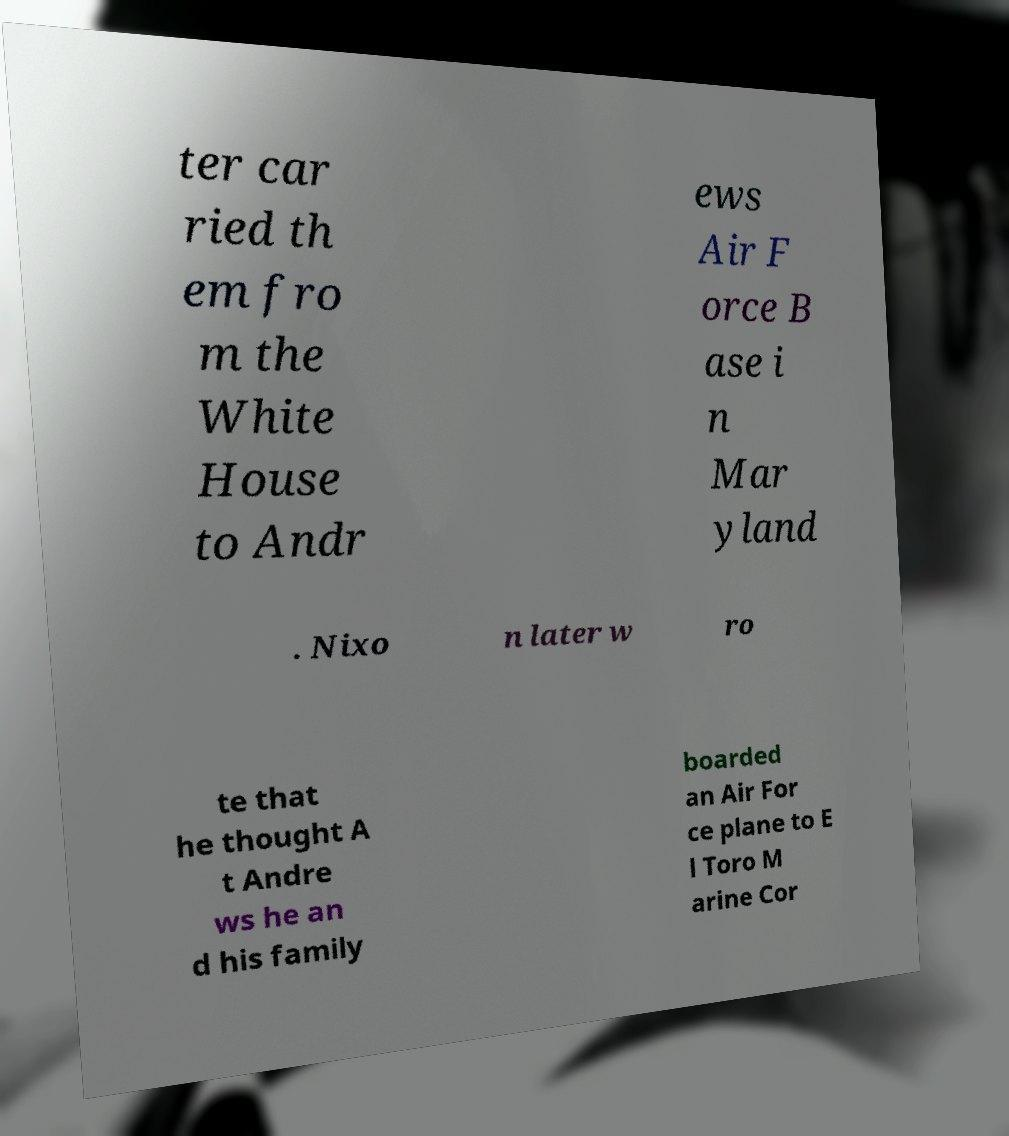Can you read and provide the text displayed in the image?This photo seems to have some interesting text. Can you extract and type it out for me? ter car ried th em fro m the White House to Andr ews Air F orce B ase i n Mar yland . Nixo n later w ro te that he thought A t Andre ws he an d his family boarded an Air For ce plane to E l Toro M arine Cor 